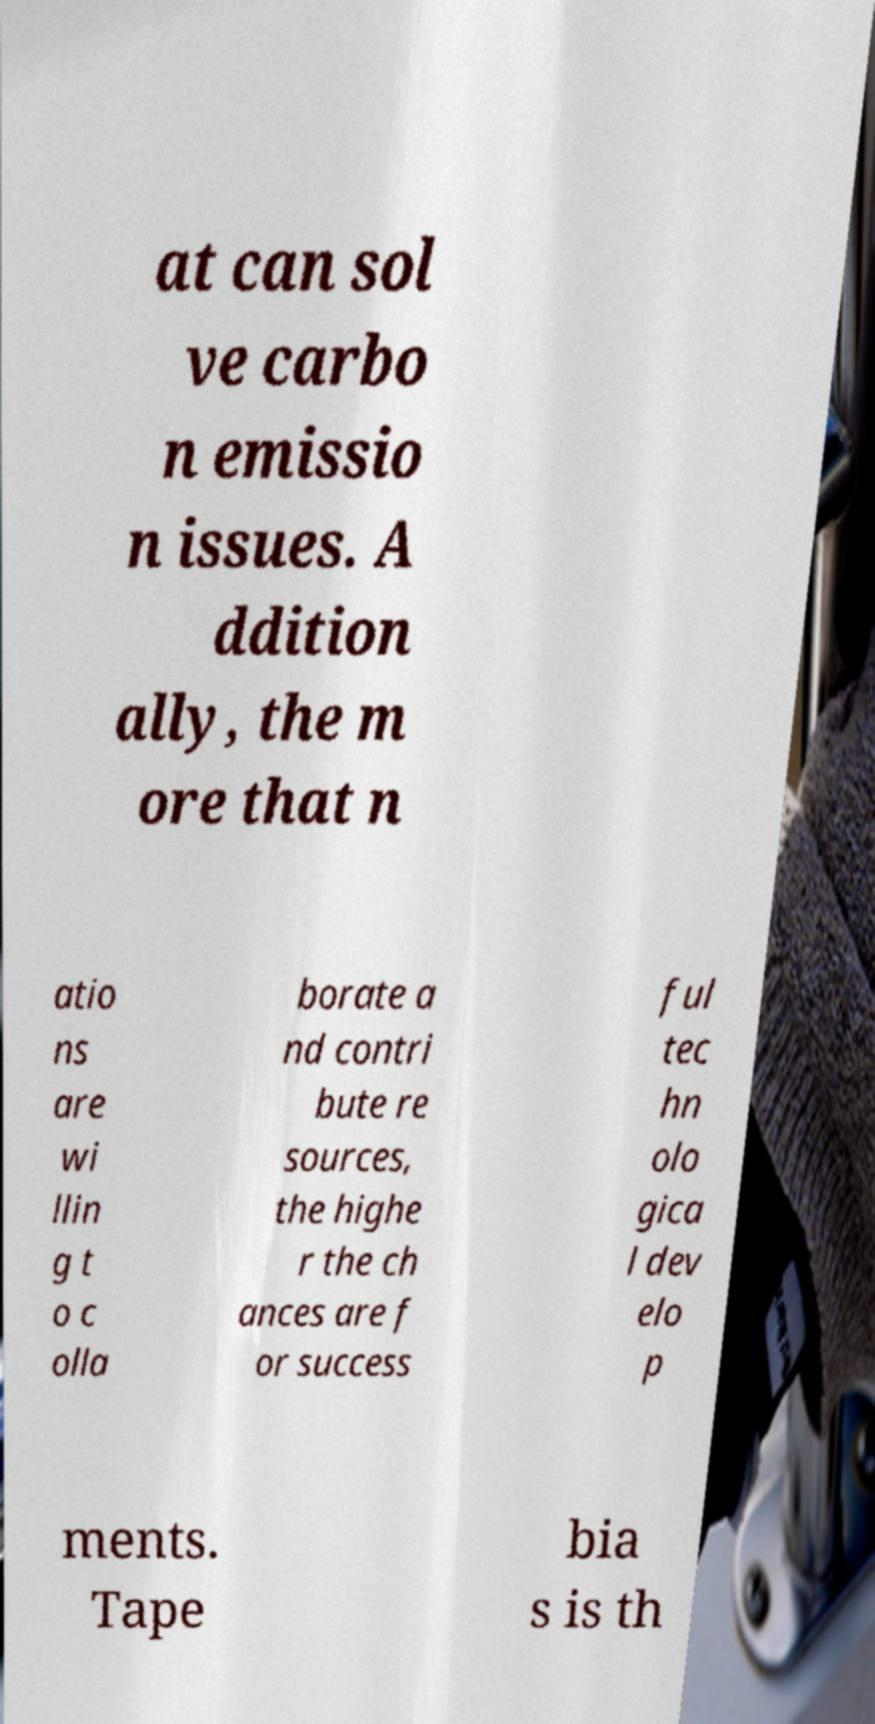There's text embedded in this image that I need extracted. Can you transcribe it verbatim? at can sol ve carbo n emissio n issues. A ddition ally, the m ore that n atio ns are wi llin g t o c olla borate a nd contri bute re sources, the highe r the ch ances are f or success ful tec hn olo gica l dev elo p ments. Tape bia s is th 